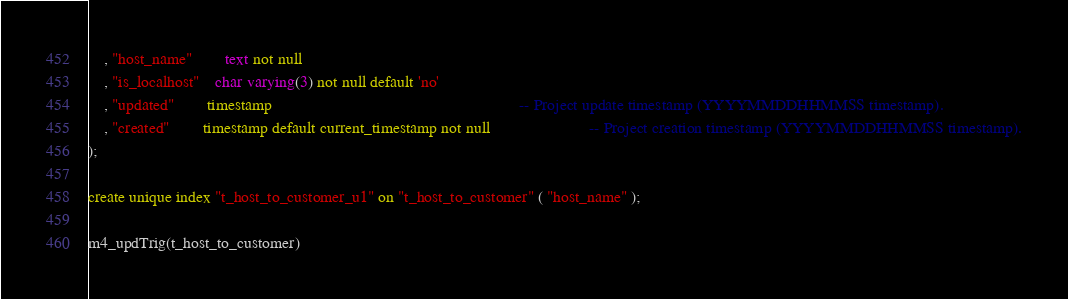Convert code to text. <code><loc_0><loc_0><loc_500><loc_500><_SQL_>	, "host_name"		text not null
	, "is_localhost"	char varying(3) not null default 'no'
	, "updated" 		timestamp 									 						-- Project update timestamp (YYYYMMDDHHMMSS timestamp).
	, "created" 		timestamp default current_timestamp not null 						-- Project creation timestamp (YYYYMMDDHHMMSS timestamp).
);

create unique index "t_host_to_customer_u1" on "t_host_to_customer" ( "host_name" );

m4_updTrig(t_host_to_customer)

</code> 